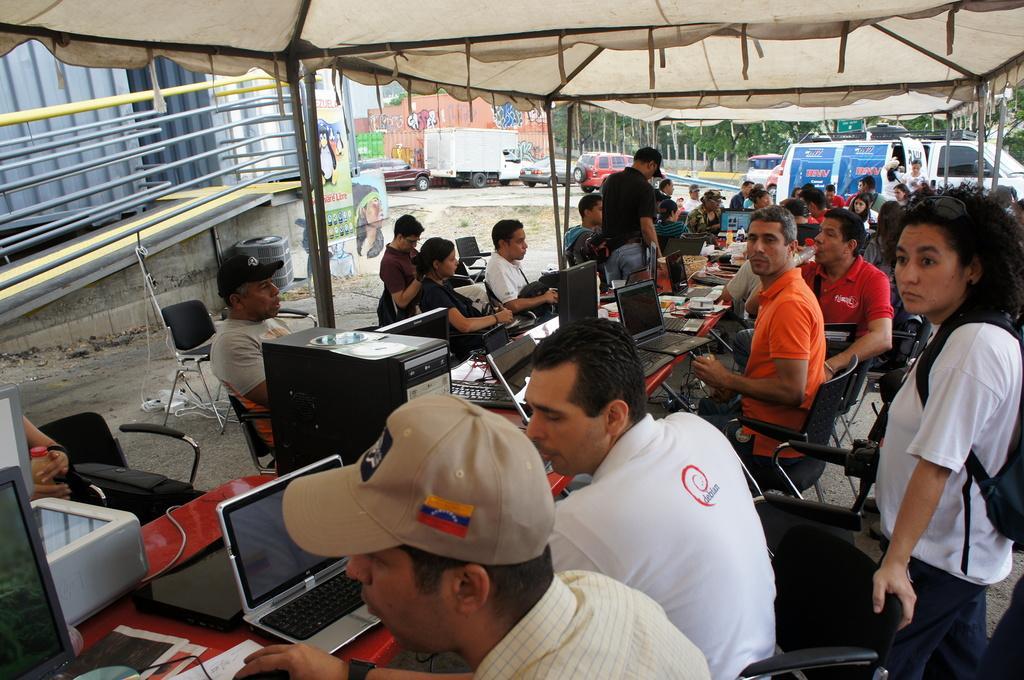Describe this image in one or two sentences. In this image which can see these people are sitting on the chairs near the table. Here we can see printers, laptops, CPUs and few more things on the table. In the background of the image we can see a building, posters on the wall, vehicles parked, trees and the tent. 